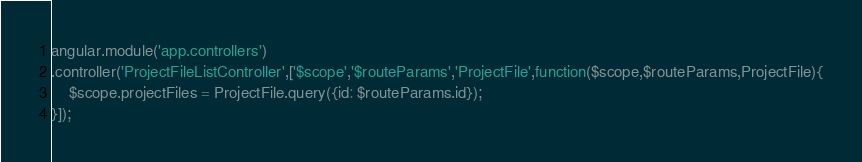Convert code to text. <code><loc_0><loc_0><loc_500><loc_500><_JavaScript_>angular.module('app.controllers')
.controller('ProjectFileListController',['$scope','$routeParams','ProjectFile',function($scope,$routeParams,ProjectFile){
	$scope.projectFiles = ProjectFile.query({id: $routeParams.id});
}]);</code> 